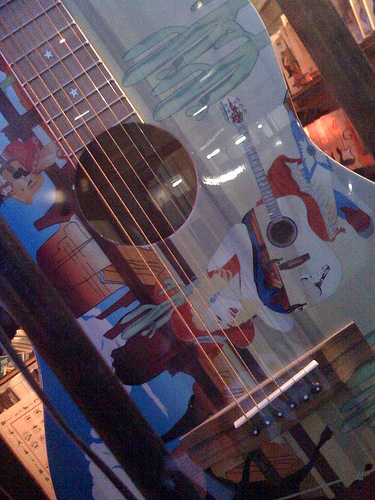<image>
Is there a painting in front of the guitar? No. The painting is not in front of the guitar. The spatial positioning shows a different relationship between these objects. 